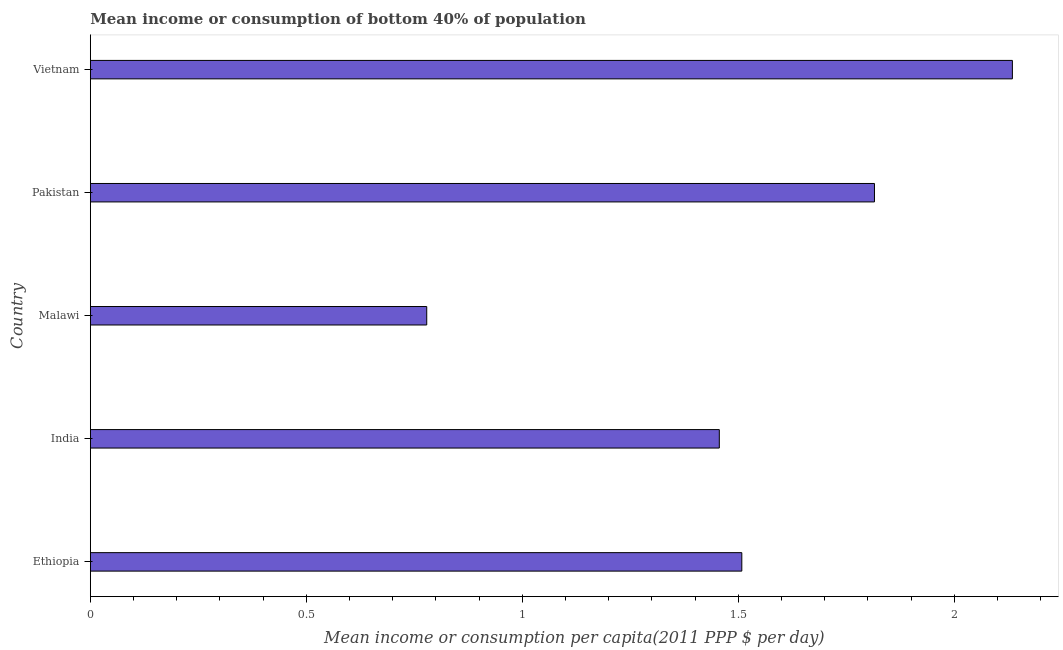Does the graph contain any zero values?
Make the answer very short. No. Does the graph contain grids?
Make the answer very short. No. What is the title of the graph?
Your answer should be compact. Mean income or consumption of bottom 40% of population. What is the label or title of the X-axis?
Offer a very short reply. Mean income or consumption per capita(2011 PPP $ per day). What is the mean income or consumption in Vietnam?
Offer a very short reply. 2.13. Across all countries, what is the maximum mean income or consumption?
Offer a terse response. 2.13. Across all countries, what is the minimum mean income or consumption?
Give a very brief answer. 0.78. In which country was the mean income or consumption maximum?
Your answer should be very brief. Vietnam. In which country was the mean income or consumption minimum?
Your answer should be very brief. Malawi. What is the sum of the mean income or consumption?
Offer a terse response. 7.69. What is the difference between the mean income or consumption in Ethiopia and Vietnam?
Provide a short and direct response. -0.63. What is the average mean income or consumption per country?
Give a very brief answer. 1.54. What is the median mean income or consumption?
Your response must be concise. 1.51. In how many countries, is the mean income or consumption greater than 0.4 $?
Ensure brevity in your answer.  5. What is the ratio of the mean income or consumption in Ethiopia to that in Vietnam?
Your response must be concise. 0.71. Is the difference between the mean income or consumption in India and Malawi greater than the difference between any two countries?
Make the answer very short. No. What is the difference between the highest and the second highest mean income or consumption?
Give a very brief answer. 0.32. What is the difference between the highest and the lowest mean income or consumption?
Ensure brevity in your answer.  1.36. In how many countries, is the mean income or consumption greater than the average mean income or consumption taken over all countries?
Keep it short and to the point. 2. How many bars are there?
Your answer should be compact. 5. Are the values on the major ticks of X-axis written in scientific E-notation?
Offer a terse response. No. What is the Mean income or consumption per capita(2011 PPP $ per day) in Ethiopia?
Your response must be concise. 1.51. What is the Mean income or consumption per capita(2011 PPP $ per day) of India?
Offer a terse response. 1.46. What is the Mean income or consumption per capita(2011 PPP $ per day) in Malawi?
Offer a very short reply. 0.78. What is the Mean income or consumption per capita(2011 PPP $ per day) in Pakistan?
Keep it short and to the point. 1.82. What is the Mean income or consumption per capita(2011 PPP $ per day) of Vietnam?
Offer a very short reply. 2.13. What is the difference between the Mean income or consumption per capita(2011 PPP $ per day) in Ethiopia and India?
Provide a short and direct response. 0.05. What is the difference between the Mean income or consumption per capita(2011 PPP $ per day) in Ethiopia and Malawi?
Ensure brevity in your answer.  0.73. What is the difference between the Mean income or consumption per capita(2011 PPP $ per day) in Ethiopia and Pakistan?
Offer a terse response. -0.31. What is the difference between the Mean income or consumption per capita(2011 PPP $ per day) in Ethiopia and Vietnam?
Your answer should be very brief. -0.63. What is the difference between the Mean income or consumption per capita(2011 PPP $ per day) in India and Malawi?
Make the answer very short. 0.68. What is the difference between the Mean income or consumption per capita(2011 PPP $ per day) in India and Pakistan?
Provide a succinct answer. -0.36. What is the difference between the Mean income or consumption per capita(2011 PPP $ per day) in India and Vietnam?
Make the answer very short. -0.68. What is the difference between the Mean income or consumption per capita(2011 PPP $ per day) in Malawi and Pakistan?
Ensure brevity in your answer.  -1.04. What is the difference between the Mean income or consumption per capita(2011 PPP $ per day) in Malawi and Vietnam?
Offer a terse response. -1.36. What is the difference between the Mean income or consumption per capita(2011 PPP $ per day) in Pakistan and Vietnam?
Make the answer very short. -0.32. What is the ratio of the Mean income or consumption per capita(2011 PPP $ per day) in Ethiopia to that in India?
Offer a terse response. 1.04. What is the ratio of the Mean income or consumption per capita(2011 PPP $ per day) in Ethiopia to that in Malawi?
Make the answer very short. 1.94. What is the ratio of the Mean income or consumption per capita(2011 PPP $ per day) in Ethiopia to that in Pakistan?
Give a very brief answer. 0.83. What is the ratio of the Mean income or consumption per capita(2011 PPP $ per day) in Ethiopia to that in Vietnam?
Your response must be concise. 0.71. What is the ratio of the Mean income or consumption per capita(2011 PPP $ per day) in India to that in Malawi?
Ensure brevity in your answer.  1.87. What is the ratio of the Mean income or consumption per capita(2011 PPP $ per day) in India to that in Pakistan?
Ensure brevity in your answer.  0.8. What is the ratio of the Mean income or consumption per capita(2011 PPP $ per day) in India to that in Vietnam?
Ensure brevity in your answer.  0.68. What is the ratio of the Mean income or consumption per capita(2011 PPP $ per day) in Malawi to that in Pakistan?
Your answer should be compact. 0.43. What is the ratio of the Mean income or consumption per capita(2011 PPP $ per day) in Malawi to that in Vietnam?
Offer a terse response. 0.36. 